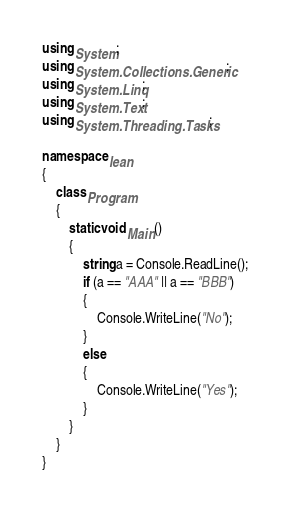Convert code to text. <code><loc_0><loc_0><loc_500><loc_500><_C#_>using System;
using System.Collections.Generic;
using System.Linq;
using System.Text;
using System.Threading.Tasks;

namespace lean
{
    class Program
    {
        static void Main()
        {
            string a = Console.ReadLine();
            if (a == "AAA" || a == "BBB")
            {
                Console.WriteLine("No");
            }
            else
            {
                Console.WriteLine("Yes");
            }
        }
    }
}
</code> 